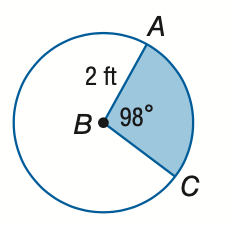Question: Find the area of the shaded sector. Round to the nearest tenth.
Choices:
A. 3.4
B. 4.6
C. 9.1
D. 12.6
Answer with the letter. Answer: A 